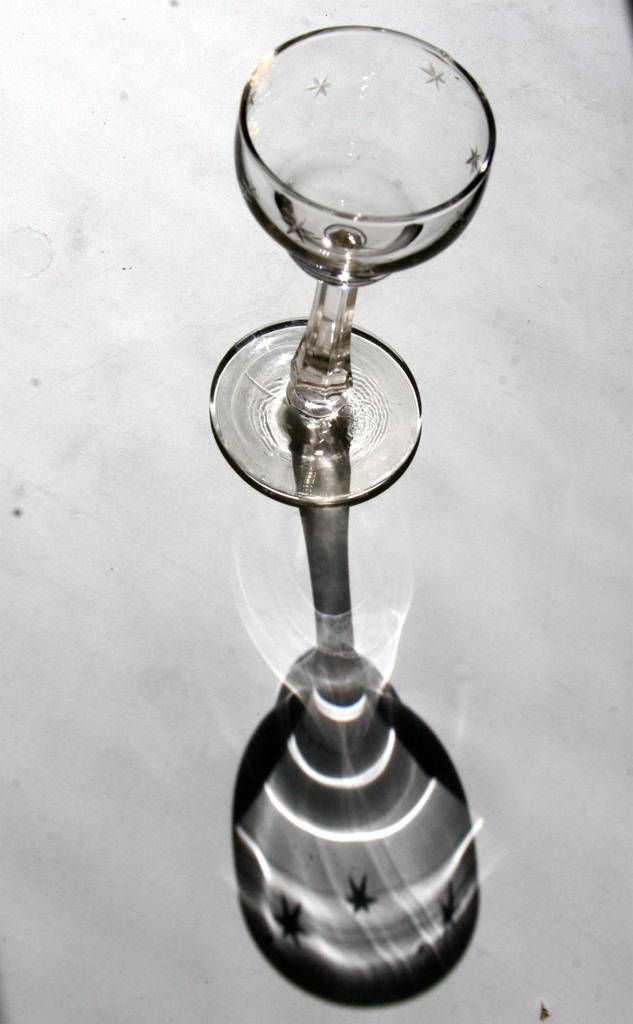What is located in the center of the image? There is a glass in the center of the image. What type of pipe can be seen connected to the glass in the image? There is no pipe connected to the glass in the image. What room is the glass located in the image? The image does not provide enough information to determine which room the glass is located in. 